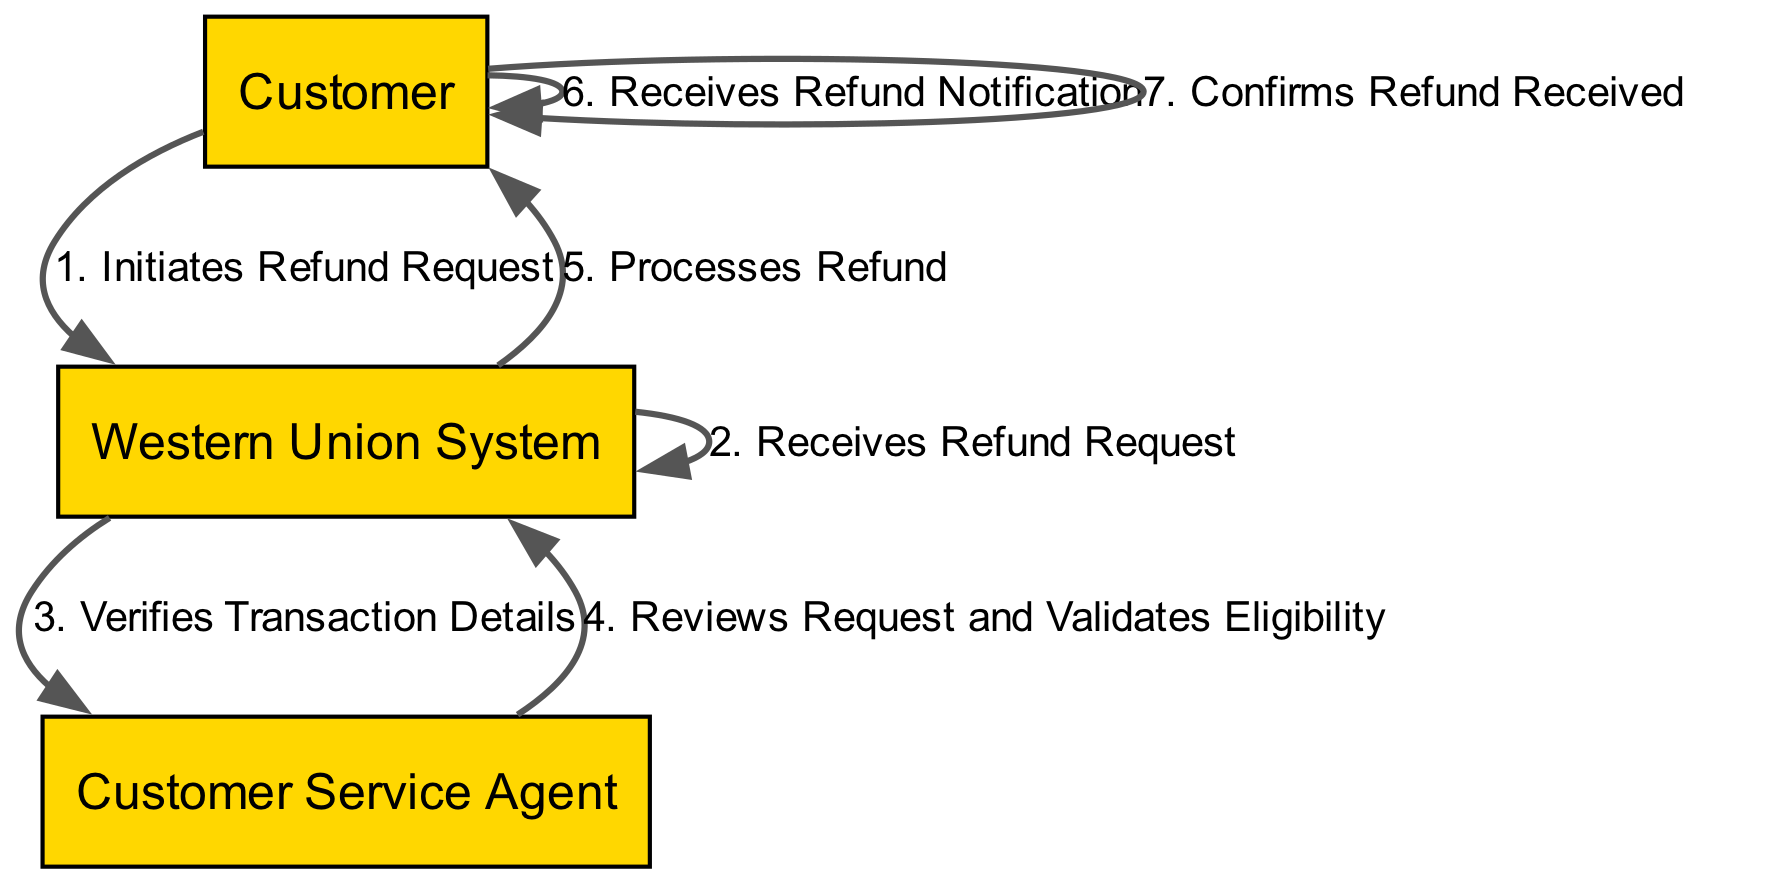What is the first action taken by the customer? The diagram indicates that the first action initiated by the customer is "Initiates Refund Request," making it the first step in the process.
Answer: Initiates Refund Request How many total steps are there in the refund process? The total number of actions or steps indicated in the diagram is counted as 7 from start to end, as represented by the sequence of elements listed.
Answer: 7 Which actor processes the refund? The actor responsible for processing the refund according to the diagram is the "Western Union System," which is clearly labeled for that specific action.
Answer: Western Union System What follows immediately after the customer initiates the refund request? Following the customer's initiation of the refund request, the next action in the sequence is that the "Western Union System" receives this refund request, indicating the direct flow of the process.
Answer: Receives Refund Request Who validates the refund eligibility? The diagram shows that the "Customer Service Agent" is tasked with reviewing the request and validating eligibility, which is crucial in determining whether the refund can proceed.
Answer: Customer Service Agent In which step does the customer receive a notification? According to the sequence, the customer receives the refund notification after the "Western Union System" processes the refund, indicating the completion of that part of the process.
Answer: Receives Refund Notification What action do customers take after receiving the refund notification? The action taken by the customer after receiving the refund notification is to "Confirms Refund Received," showing the final acknowledgment in the process of the refund.
Answer: Confirms Refund Received Which actor initiates the refund request? The initial actor in the sequence of the refund process is the "Customer," who initiates the sequence by requesting a refund.
Answer: Customer 